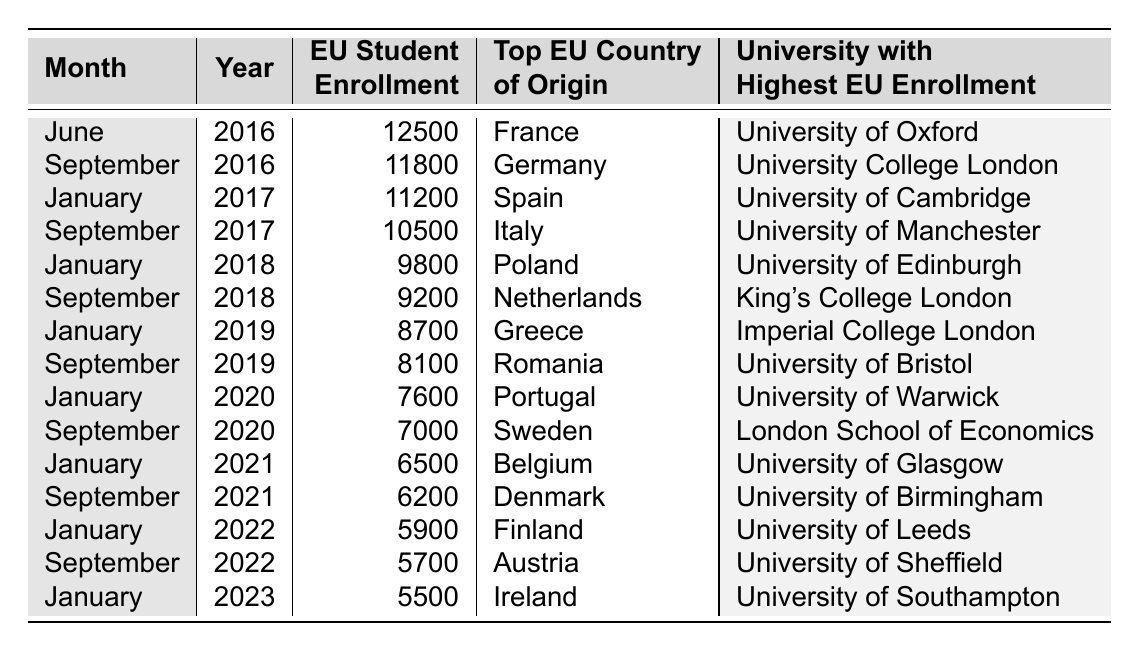What was the EU student enrollment in January 2023? The table shows that the EU student enrollment in January 2023 is listed as 5500.
Answer: 5500 Which university had the highest EU enrollment in September 2020? According to the table, the university with the highest EU enrollment in September 2020 is the London School of Economics.
Answer: London School of Economics How many EU students were enrolled in September 2017 compared to January 2018? In September 2017, the enrollment was 10500, and in January 2018, it was 9800. The difference is 10500 - 9800 = 700.
Answer: 700 What was the top EU country of origin for students in January 2020? The table states that the top EU country of origin in January 2020 was Portugal.
Answer: Portugal Is it true that the number of EU students enrolled in UK universities has decreased every year since 2016? Analyzing the data, the enrollment has decreased each enrollment checkpoint from 2016 to 2023.
Answer: Yes What was the percent decrease in EU student enrollment from September 2016 to January 2021? The enrollment in September 2016 was 11800 and in January 2021 it was 6500. The decrease is 11800 - 6500 = 5300. The percent decrease is (5300/11800) * 100 ≈ 44.91%.
Answer: Approximately 44.91% Which month and year had the lowest EU student enrollment in the table? The lowest EU student enrollment in the table occurred in January 2023, where the enrollment was 5500.
Answer: January 2023 List the three universities with the highest EU enrollment in 2019. The table indicates that in January 2019 the enrollment was 8700 (Imperial College London), in September 2019 it was 8100 (University of Bristol). The highest was in June 2016 (University of Oxford) with 12500, which is pre-2019 but the highest overall. Combining, the top three for 2019 would include Imperial College London, University of Bristol, and if we consider overall, University of Oxford.
Answer: Imperial College London, University of Bristol, University of Oxford What was the trend in EU student enrollment from 2016 to 2021? The data show a consistent decline in student enrollment from June 2016 (12500) to January 2021 (6500), with each year exhibiting lower enrollment compared to the previous year.
Answer: Declining trend How many more EU students were enrolled in September 2016 compared to September 2021? The table records 11800 EU students in September 2016 and 6200 in September 2021. The difference is 11800 - 6200 = 5600.
Answer: 5600 What is the average EU student enrollment for the years 2021 to 2023? The enrollment for the years February and September from 2021 to 2023 includes 6500, 6200, 5900, 5700, and 5500. Adding these gives a total of 29500 and dividing by 5 results in an average of 5900.
Answer: 5900 